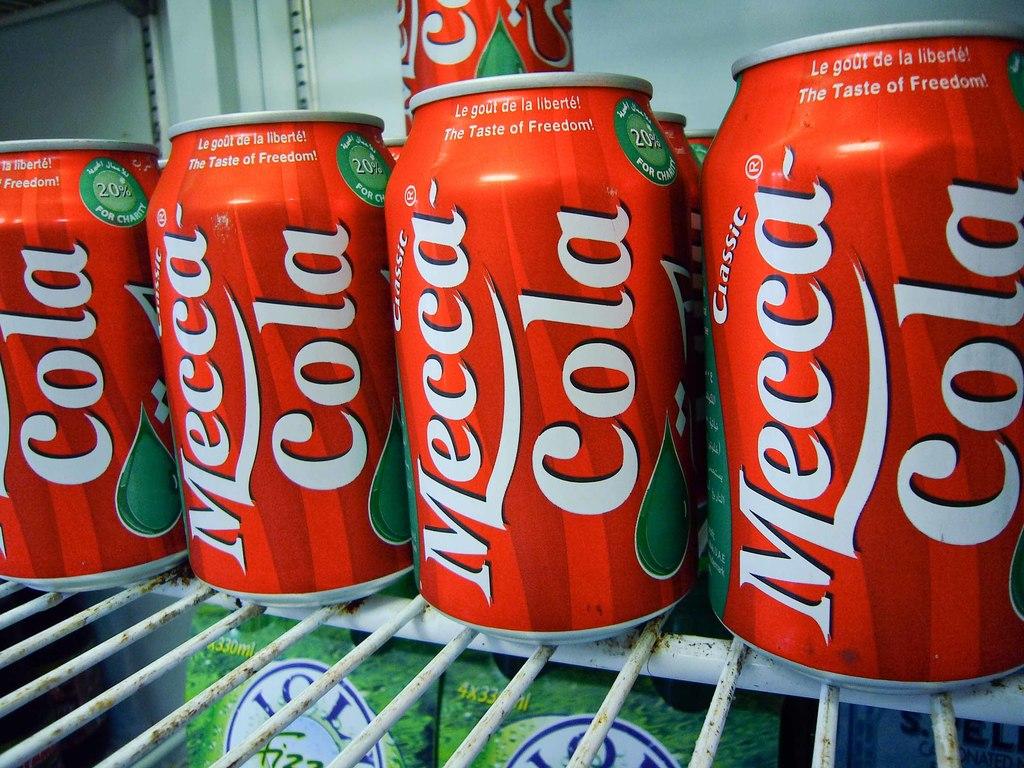What kind if drink is in the cans?
Your response must be concise. Mecca cola. This cola is the taste of what?
Provide a short and direct response. Freedom. 